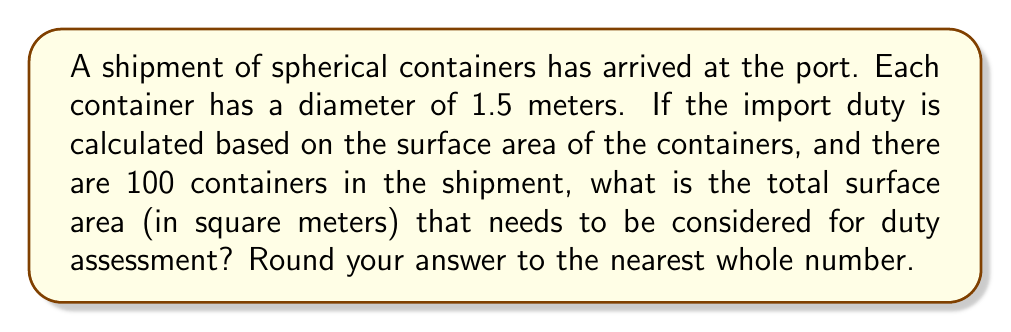Help me with this question. To solve this problem, we need to follow these steps:

1. Calculate the surface area of a single spherical container:
   The formula for the surface area of a sphere is $A = 4\pi r^2$, where $r$ is the radius.
   
   Diameter = 1.5 m, so radius = 0.75 m
   
   $A = 4\pi (0.75)^2$
   $A = 4\pi (0.5625)$
   $A \approx 7.0686 \text{ m}^2$

2. Multiply the surface area of one container by the total number of containers:
   Total surface area = $7.0686 \times 100 = 706.86 \text{ m}^2$

3. Round to the nearest whole number:
   $706.86 \text{ m}^2 \approx 707 \text{ m}^2$

Therefore, the total surface area to be considered for duty assessment is approximately 707 square meters.
Answer: 707 m² 